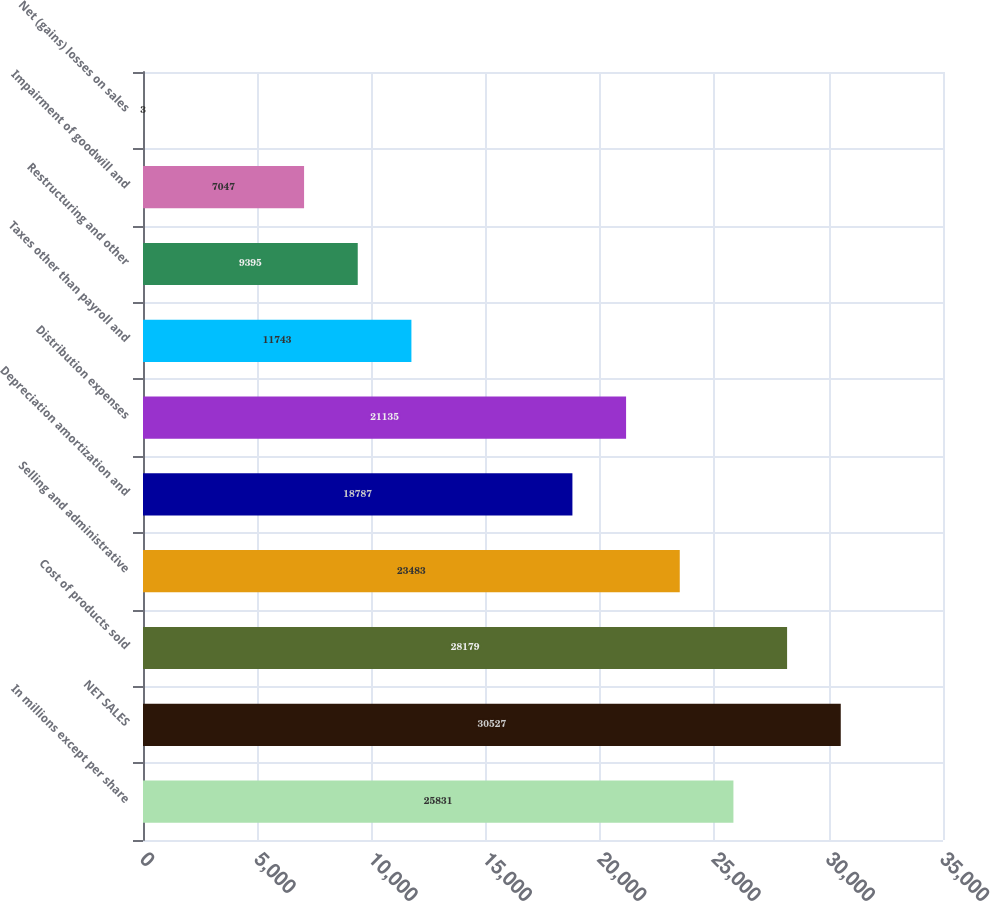Convert chart. <chart><loc_0><loc_0><loc_500><loc_500><bar_chart><fcel>In millions except per share<fcel>NET SALES<fcel>Cost of products sold<fcel>Selling and administrative<fcel>Depreciation amortization and<fcel>Distribution expenses<fcel>Taxes other than payroll and<fcel>Restructuring and other<fcel>Impairment of goodwill and<fcel>Net (gains) losses on sales<nl><fcel>25831<fcel>30527<fcel>28179<fcel>23483<fcel>18787<fcel>21135<fcel>11743<fcel>9395<fcel>7047<fcel>3<nl></chart> 